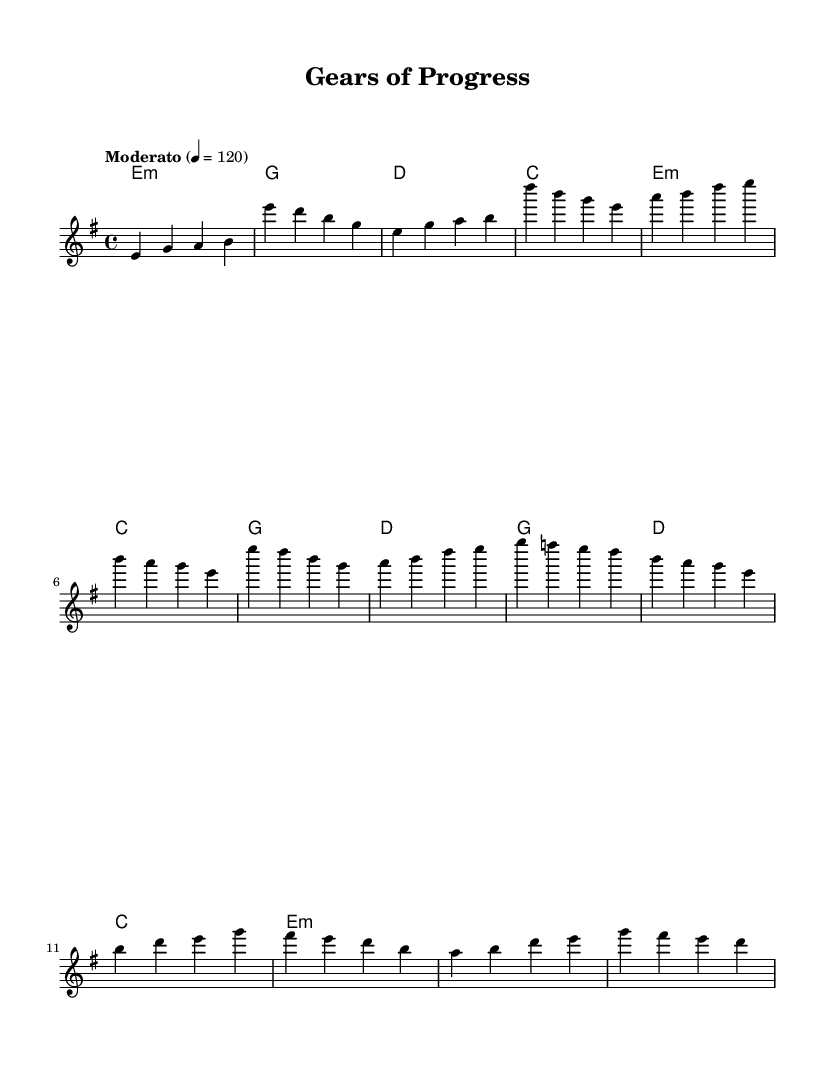What is the key signature of this music? The key signature is E minor, which has one sharp (F#).
Answer: E minor What is the time signature of this music? The time signature is indicated at the beginning of the score; here, it is 4/4, meaning there are four beats per measure.
Answer: 4/4 What is the tempo of this piece? The tempo marking is indicated as "Moderato," with a metronome marking of 120 beats per minute, which suggests a moderate pace.
Answer: Moderato How many measures are in the melody? To determine the number of measures, we can count the distinct groupings of notes separated by vertical lines (bar lines) in the melody section. There are 16 measures in total.
Answer: 16 What chord follows the A minor chord in the verse? By examining the chord progression specified in the harmonies section, after A minor, the next chord is D major, as indicated in the chord mode.
Answer: D Which section of the music contains a bridge? The bridge is typically a contrasting section between verse and chorus; in this piece, it is clearly labeled as "Bridge" and starts after the chorus.
Answer: Bridge What is the first note in the melody? The first note in the melody is indicated at the beginning, it is E in the first measure.
Answer: E 